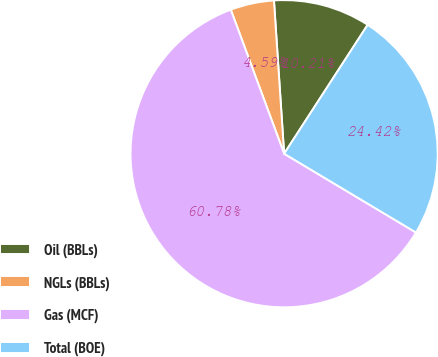<chart> <loc_0><loc_0><loc_500><loc_500><pie_chart><fcel>Oil (BBLs)<fcel>NGLs (BBLs)<fcel>Gas (MCF)<fcel>Total (BOE)<nl><fcel>10.21%<fcel>4.59%<fcel>60.78%<fcel>24.42%<nl></chart> 